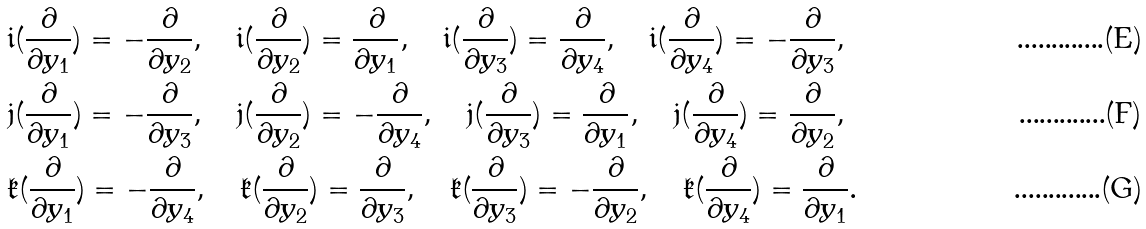Convert formula to latex. <formula><loc_0><loc_0><loc_500><loc_500>& \mathfrak { i } ( \frac { \partial } { \partial y _ { 1 } } ) = - \frac { \partial } { \partial y _ { 2 } } , \quad \mathfrak { i } ( \frac { \partial } { \partial y _ { 2 } } ) = \frac { \partial } { \partial y _ { 1 } } , \quad \mathfrak { i } ( \frac { \partial } { \partial y _ { 3 } } ) = \frac { \partial } { \partial y _ { 4 } } , \quad \mathfrak { i } ( \frac { \partial } { \partial y _ { 4 } } ) = - \frac { \partial } { \partial y _ { 3 } } , \\ & \mathfrak { j } ( \frac { \partial } { \partial y _ { 1 } } ) = - \frac { \partial } { \partial y _ { 3 } } , \quad \mathfrak { j } ( \frac { \partial } { \partial y _ { 2 } } ) = - \frac { \partial } { \partial y _ { 4 } } , \quad \mathfrak { j } ( \frac { \partial } { \partial y _ { 3 } } ) = \frac { \partial } { \partial y _ { 1 } } , \quad \mathfrak { j } ( \frac { \partial } { \partial y _ { 4 } } ) = \frac { \partial } { \partial y _ { 2 } } , \\ & \mathfrak { k } ( \frac { \partial } { \partial y _ { 1 } } ) = - \frac { \partial } { \partial y _ { 4 } } , \quad \mathfrak { k } ( \frac { \partial } { \partial y _ { 2 } } ) = \frac { \partial } { \partial y _ { 3 } } , \quad \mathfrak { k } ( \frac { \partial } { \partial y _ { 3 } } ) = - \frac { \partial } { \partial y _ { 2 } } , \quad \mathfrak { k } ( \frac { \partial } { \partial y _ { 4 } } ) = \frac { \partial } { \partial y _ { 1 } } .</formula> 